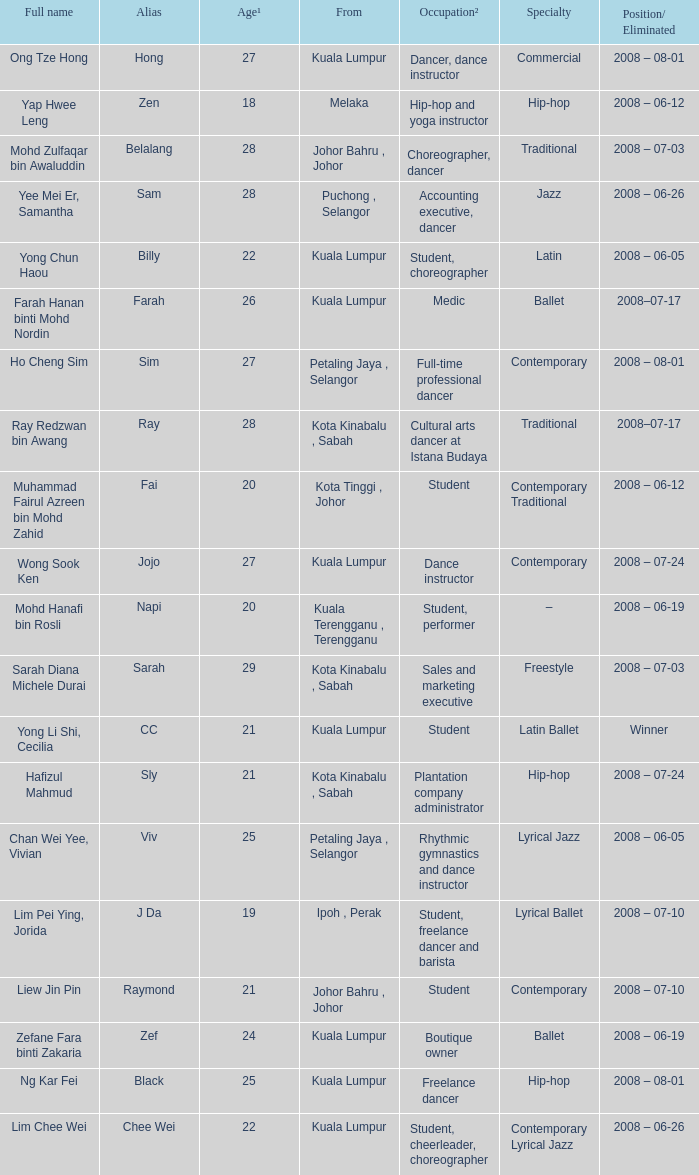What is Occupation², when Age¹ is greater than 24, when Alias is "Black"? Freelance dancer. 